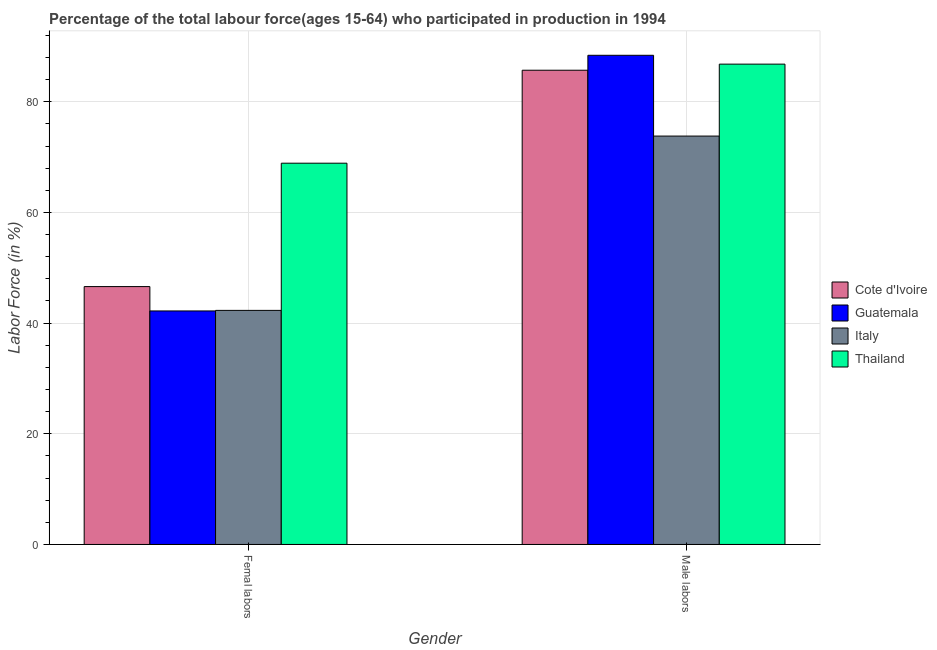How many different coloured bars are there?
Your response must be concise. 4. How many groups of bars are there?
Keep it short and to the point. 2. Are the number of bars per tick equal to the number of legend labels?
Keep it short and to the point. Yes. How many bars are there on the 2nd tick from the left?
Ensure brevity in your answer.  4. What is the label of the 1st group of bars from the left?
Your response must be concise. Femal labors. What is the percentage of male labour force in Italy?
Your answer should be very brief. 73.8. Across all countries, what is the maximum percentage of male labour force?
Keep it short and to the point. 88.4. Across all countries, what is the minimum percentage of female labor force?
Make the answer very short. 42.2. In which country was the percentage of female labor force maximum?
Your answer should be very brief. Thailand. What is the difference between the percentage of female labor force in Thailand and that in Italy?
Offer a very short reply. 26.6. What is the difference between the percentage of female labor force in Cote d'Ivoire and the percentage of male labour force in Guatemala?
Give a very brief answer. -41.8. What is the average percentage of male labour force per country?
Give a very brief answer. 83.68. What is the difference between the percentage of female labor force and percentage of male labour force in Italy?
Give a very brief answer. -31.5. What is the ratio of the percentage of male labour force in Cote d'Ivoire to that in Guatemala?
Provide a succinct answer. 0.97. What does the 4th bar from the left in Femal labors represents?
Ensure brevity in your answer.  Thailand. What does the 1st bar from the right in Femal labors represents?
Keep it short and to the point. Thailand. What is the difference between two consecutive major ticks on the Y-axis?
Give a very brief answer. 20. Does the graph contain grids?
Offer a very short reply. Yes. How are the legend labels stacked?
Give a very brief answer. Vertical. What is the title of the graph?
Offer a very short reply. Percentage of the total labour force(ages 15-64) who participated in production in 1994. What is the label or title of the X-axis?
Ensure brevity in your answer.  Gender. What is the Labor Force (in %) of Cote d'Ivoire in Femal labors?
Keep it short and to the point. 46.6. What is the Labor Force (in %) of Guatemala in Femal labors?
Your answer should be very brief. 42.2. What is the Labor Force (in %) of Italy in Femal labors?
Give a very brief answer. 42.3. What is the Labor Force (in %) of Thailand in Femal labors?
Provide a succinct answer. 68.9. What is the Labor Force (in %) in Cote d'Ivoire in Male labors?
Keep it short and to the point. 85.7. What is the Labor Force (in %) in Guatemala in Male labors?
Ensure brevity in your answer.  88.4. What is the Labor Force (in %) in Italy in Male labors?
Give a very brief answer. 73.8. What is the Labor Force (in %) in Thailand in Male labors?
Make the answer very short. 86.8. Across all Gender, what is the maximum Labor Force (in %) in Cote d'Ivoire?
Your response must be concise. 85.7. Across all Gender, what is the maximum Labor Force (in %) in Guatemala?
Your response must be concise. 88.4. Across all Gender, what is the maximum Labor Force (in %) in Italy?
Provide a succinct answer. 73.8. Across all Gender, what is the maximum Labor Force (in %) in Thailand?
Your response must be concise. 86.8. Across all Gender, what is the minimum Labor Force (in %) of Cote d'Ivoire?
Give a very brief answer. 46.6. Across all Gender, what is the minimum Labor Force (in %) of Guatemala?
Offer a very short reply. 42.2. Across all Gender, what is the minimum Labor Force (in %) of Italy?
Your response must be concise. 42.3. Across all Gender, what is the minimum Labor Force (in %) in Thailand?
Your answer should be compact. 68.9. What is the total Labor Force (in %) in Cote d'Ivoire in the graph?
Your answer should be compact. 132.3. What is the total Labor Force (in %) of Guatemala in the graph?
Make the answer very short. 130.6. What is the total Labor Force (in %) in Italy in the graph?
Ensure brevity in your answer.  116.1. What is the total Labor Force (in %) in Thailand in the graph?
Offer a terse response. 155.7. What is the difference between the Labor Force (in %) of Cote d'Ivoire in Femal labors and that in Male labors?
Offer a very short reply. -39.1. What is the difference between the Labor Force (in %) of Guatemala in Femal labors and that in Male labors?
Ensure brevity in your answer.  -46.2. What is the difference between the Labor Force (in %) of Italy in Femal labors and that in Male labors?
Ensure brevity in your answer.  -31.5. What is the difference between the Labor Force (in %) in Thailand in Femal labors and that in Male labors?
Provide a short and direct response. -17.9. What is the difference between the Labor Force (in %) in Cote d'Ivoire in Femal labors and the Labor Force (in %) in Guatemala in Male labors?
Provide a succinct answer. -41.8. What is the difference between the Labor Force (in %) in Cote d'Ivoire in Femal labors and the Labor Force (in %) in Italy in Male labors?
Provide a succinct answer. -27.2. What is the difference between the Labor Force (in %) of Cote d'Ivoire in Femal labors and the Labor Force (in %) of Thailand in Male labors?
Offer a terse response. -40.2. What is the difference between the Labor Force (in %) of Guatemala in Femal labors and the Labor Force (in %) of Italy in Male labors?
Make the answer very short. -31.6. What is the difference between the Labor Force (in %) of Guatemala in Femal labors and the Labor Force (in %) of Thailand in Male labors?
Provide a succinct answer. -44.6. What is the difference between the Labor Force (in %) of Italy in Femal labors and the Labor Force (in %) of Thailand in Male labors?
Your answer should be very brief. -44.5. What is the average Labor Force (in %) of Cote d'Ivoire per Gender?
Give a very brief answer. 66.15. What is the average Labor Force (in %) in Guatemala per Gender?
Provide a succinct answer. 65.3. What is the average Labor Force (in %) of Italy per Gender?
Provide a short and direct response. 58.05. What is the average Labor Force (in %) in Thailand per Gender?
Provide a short and direct response. 77.85. What is the difference between the Labor Force (in %) of Cote d'Ivoire and Labor Force (in %) of Guatemala in Femal labors?
Provide a short and direct response. 4.4. What is the difference between the Labor Force (in %) in Cote d'Ivoire and Labor Force (in %) in Thailand in Femal labors?
Offer a very short reply. -22.3. What is the difference between the Labor Force (in %) in Guatemala and Labor Force (in %) in Italy in Femal labors?
Offer a very short reply. -0.1. What is the difference between the Labor Force (in %) in Guatemala and Labor Force (in %) in Thailand in Femal labors?
Your answer should be compact. -26.7. What is the difference between the Labor Force (in %) in Italy and Labor Force (in %) in Thailand in Femal labors?
Your answer should be very brief. -26.6. What is the difference between the Labor Force (in %) in Cote d'Ivoire and Labor Force (in %) in Italy in Male labors?
Your answer should be very brief. 11.9. What is the difference between the Labor Force (in %) of Cote d'Ivoire and Labor Force (in %) of Thailand in Male labors?
Provide a succinct answer. -1.1. What is the difference between the Labor Force (in %) in Guatemala and Labor Force (in %) in Thailand in Male labors?
Provide a short and direct response. 1.6. What is the ratio of the Labor Force (in %) of Cote d'Ivoire in Femal labors to that in Male labors?
Your response must be concise. 0.54. What is the ratio of the Labor Force (in %) in Guatemala in Femal labors to that in Male labors?
Your response must be concise. 0.48. What is the ratio of the Labor Force (in %) in Italy in Femal labors to that in Male labors?
Give a very brief answer. 0.57. What is the ratio of the Labor Force (in %) in Thailand in Femal labors to that in Male labors?
Your answer should be compact. 0.79. What is the difference between the highest and the second highest Labor Force (in %) in Cote d'Ivoire?
Give a very brief answer. 39.1. What is the difference between the highest and the second highest Labor Force (in %) in Guatemala?
Keep it short and to the point. 46.2. What is the difference between the highest and the second highest Labor Force (in %) in Italy?
Your response must be concise. 31.5. What is the difference between the highest and the second highest Labor Force (in %) in Thailand?
Your response must be concise. 17.9. What is the difference between the highest and the lowest Labor Force (in %) in Cote d'Ivoire?
Your response must be concise. 39.1. What is the difference between the highest and the lowest Labor Force (in %) of Guatemala?
Your answer should be very brief. 46.2. What is the difference between the highest and the lowest Labor Force (in %) of Italy?
Keep it short and to the point. 31.5. What is the difference between the highest and the lowest Labor Force (in %) of Thailand?
Offer a terse response. 17.9. 